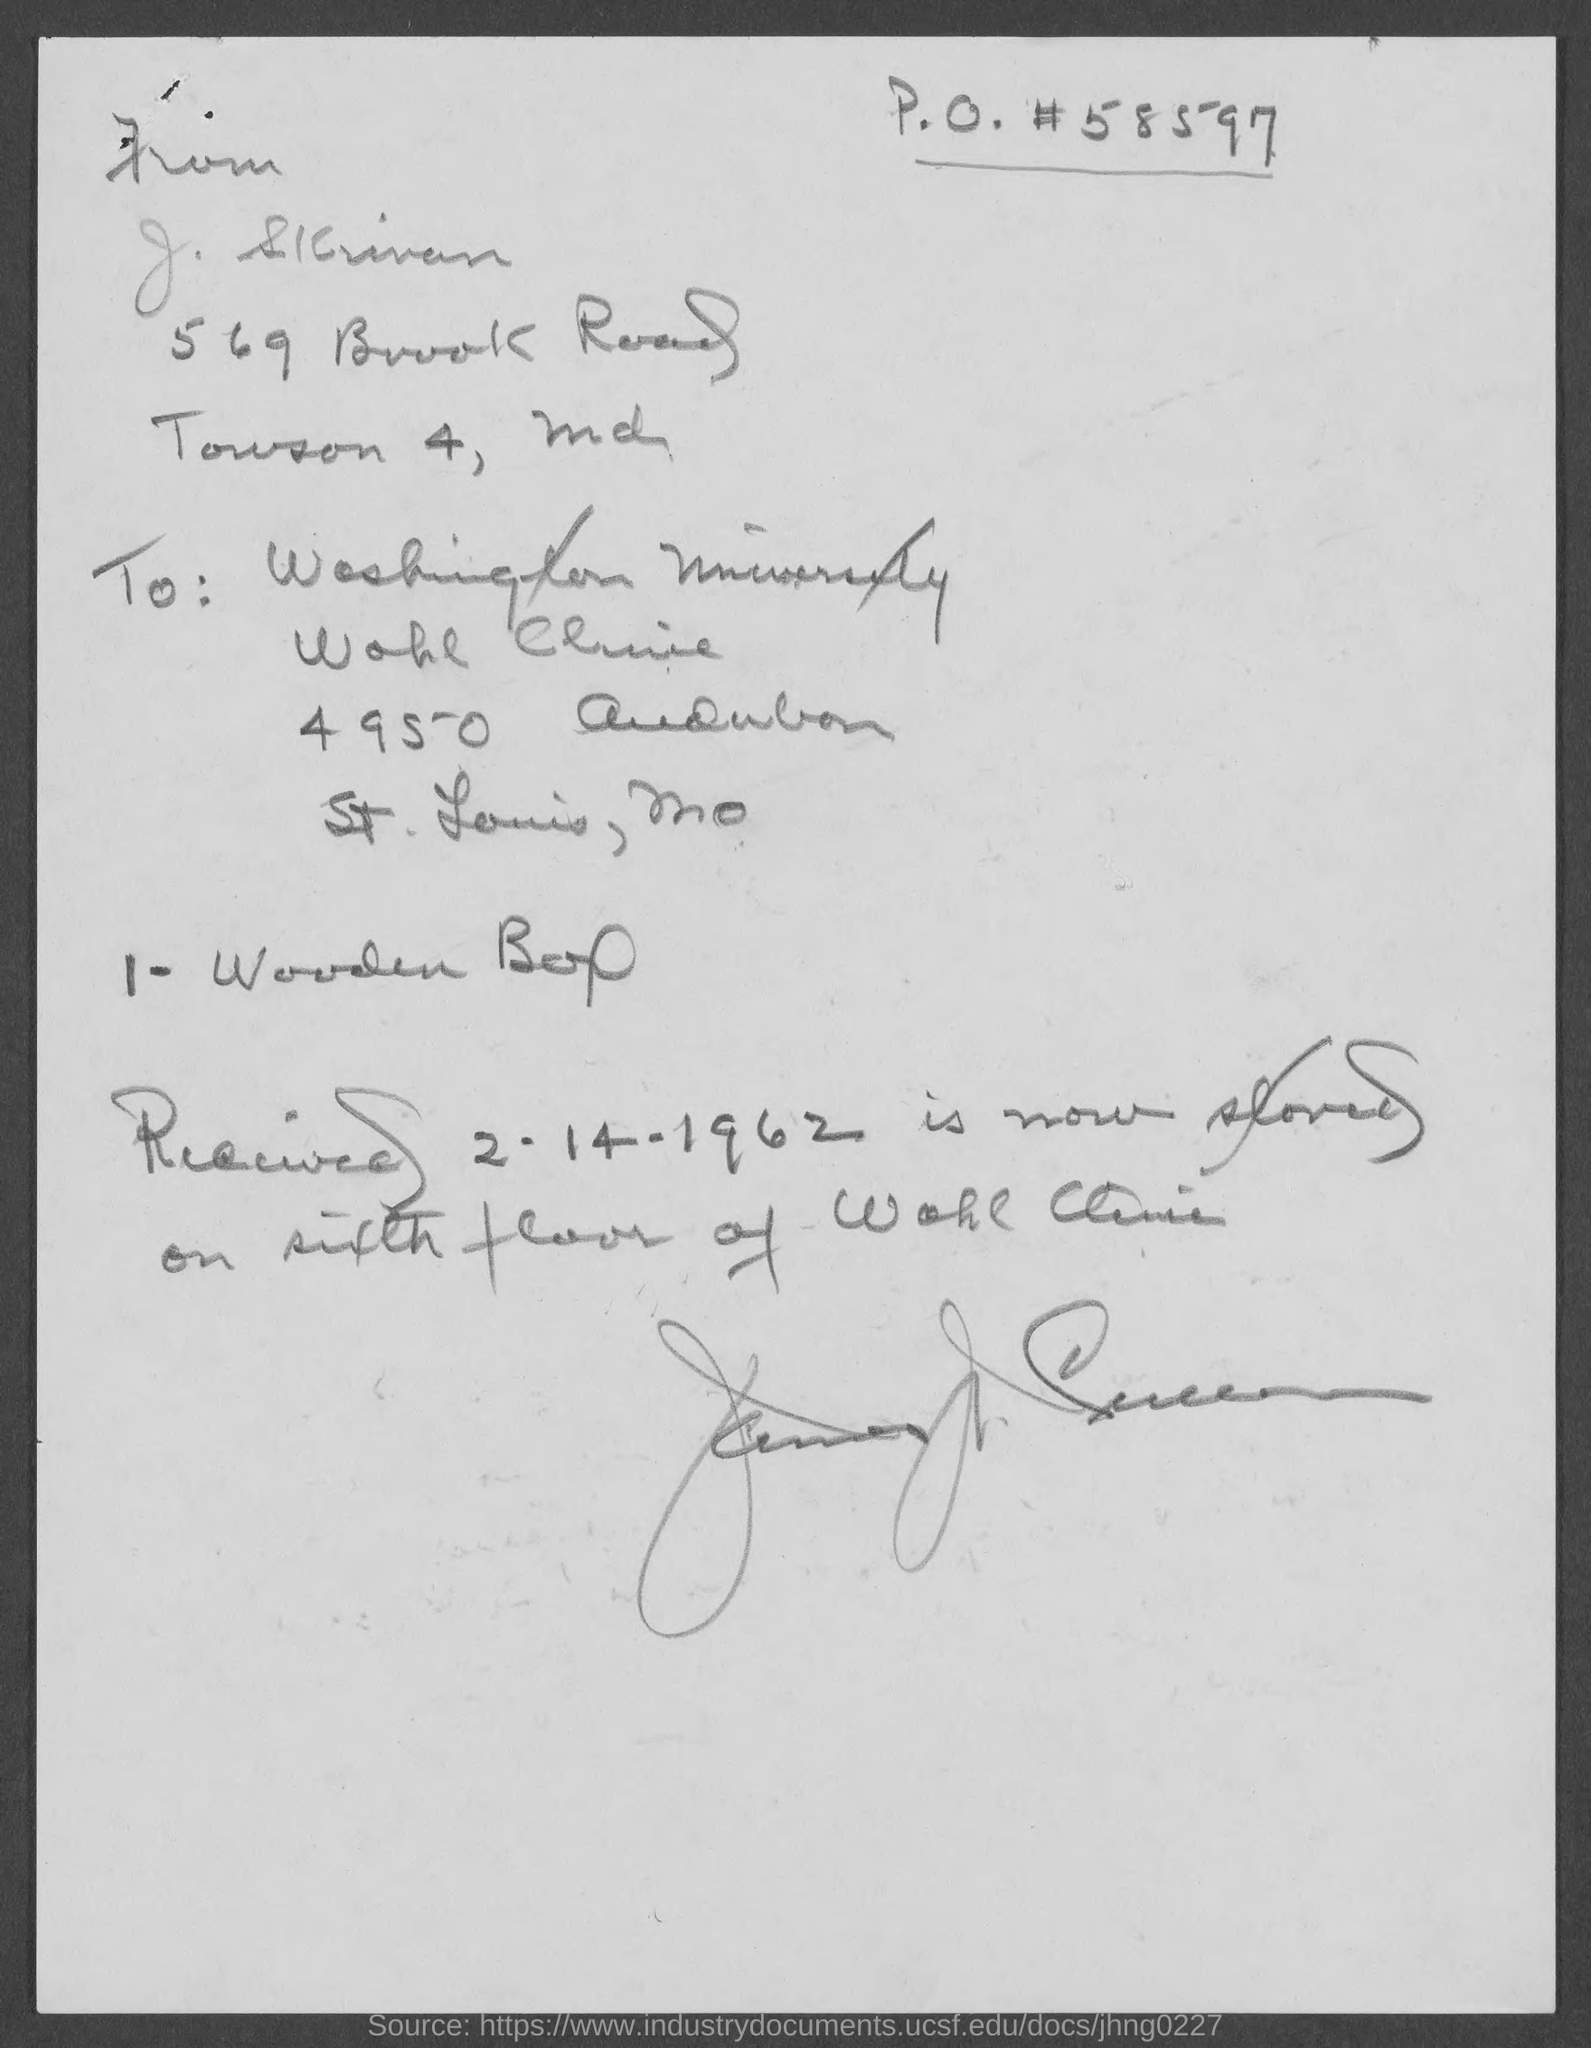List a handful of essential elements in this visual. The letter is addressed to Washington University. The received date mentioned in the letter is 2-14-1962. 